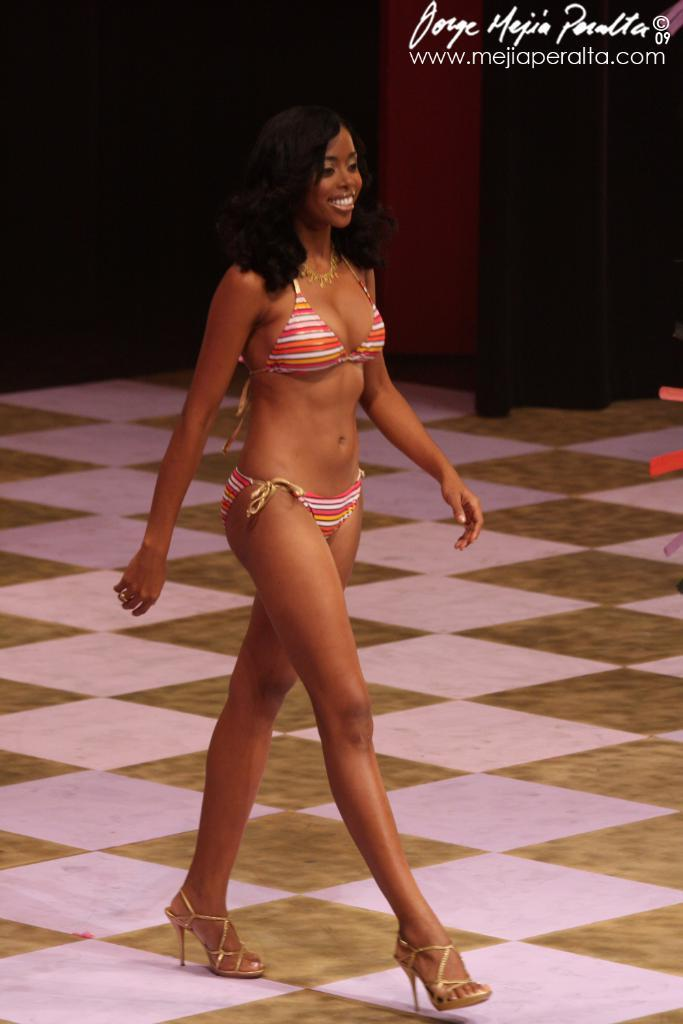Who or what is present in the image? There is a person in the image. What can be seen beneath the person's feet? The ground is visible in the image. What is located on the right side of the image? There is an object on the right side of the image. What architectural feature is present in the image? There is a wall in the image. What type of window treatment is associated with the wall? There are curtains associated with the wall. What type of space attraction can be seen in the image? There is no space attraction present in the image. What school is the person attending in the image? There is no indication of a school or any educational context in the image. 